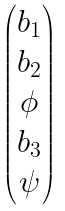Convert formula to latex. <formula><loc_0><loc_0><loc_500><loc_500>\begin{pmatrix} b _ { 1 } \\ b _ { 2 } \\ \phi \\ b _ { 3 } \\ \psi \end{pmatrix}</formula> 